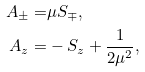<formula> <loc_0><loc_0><loc_500><loc_500>A _ { \pm } = & \mu S _ { \mp } , \\ A _ { z } = & - S _ { z } + \frac { 1 } { 2 \mu ^ { 2 } } ,</formula> 